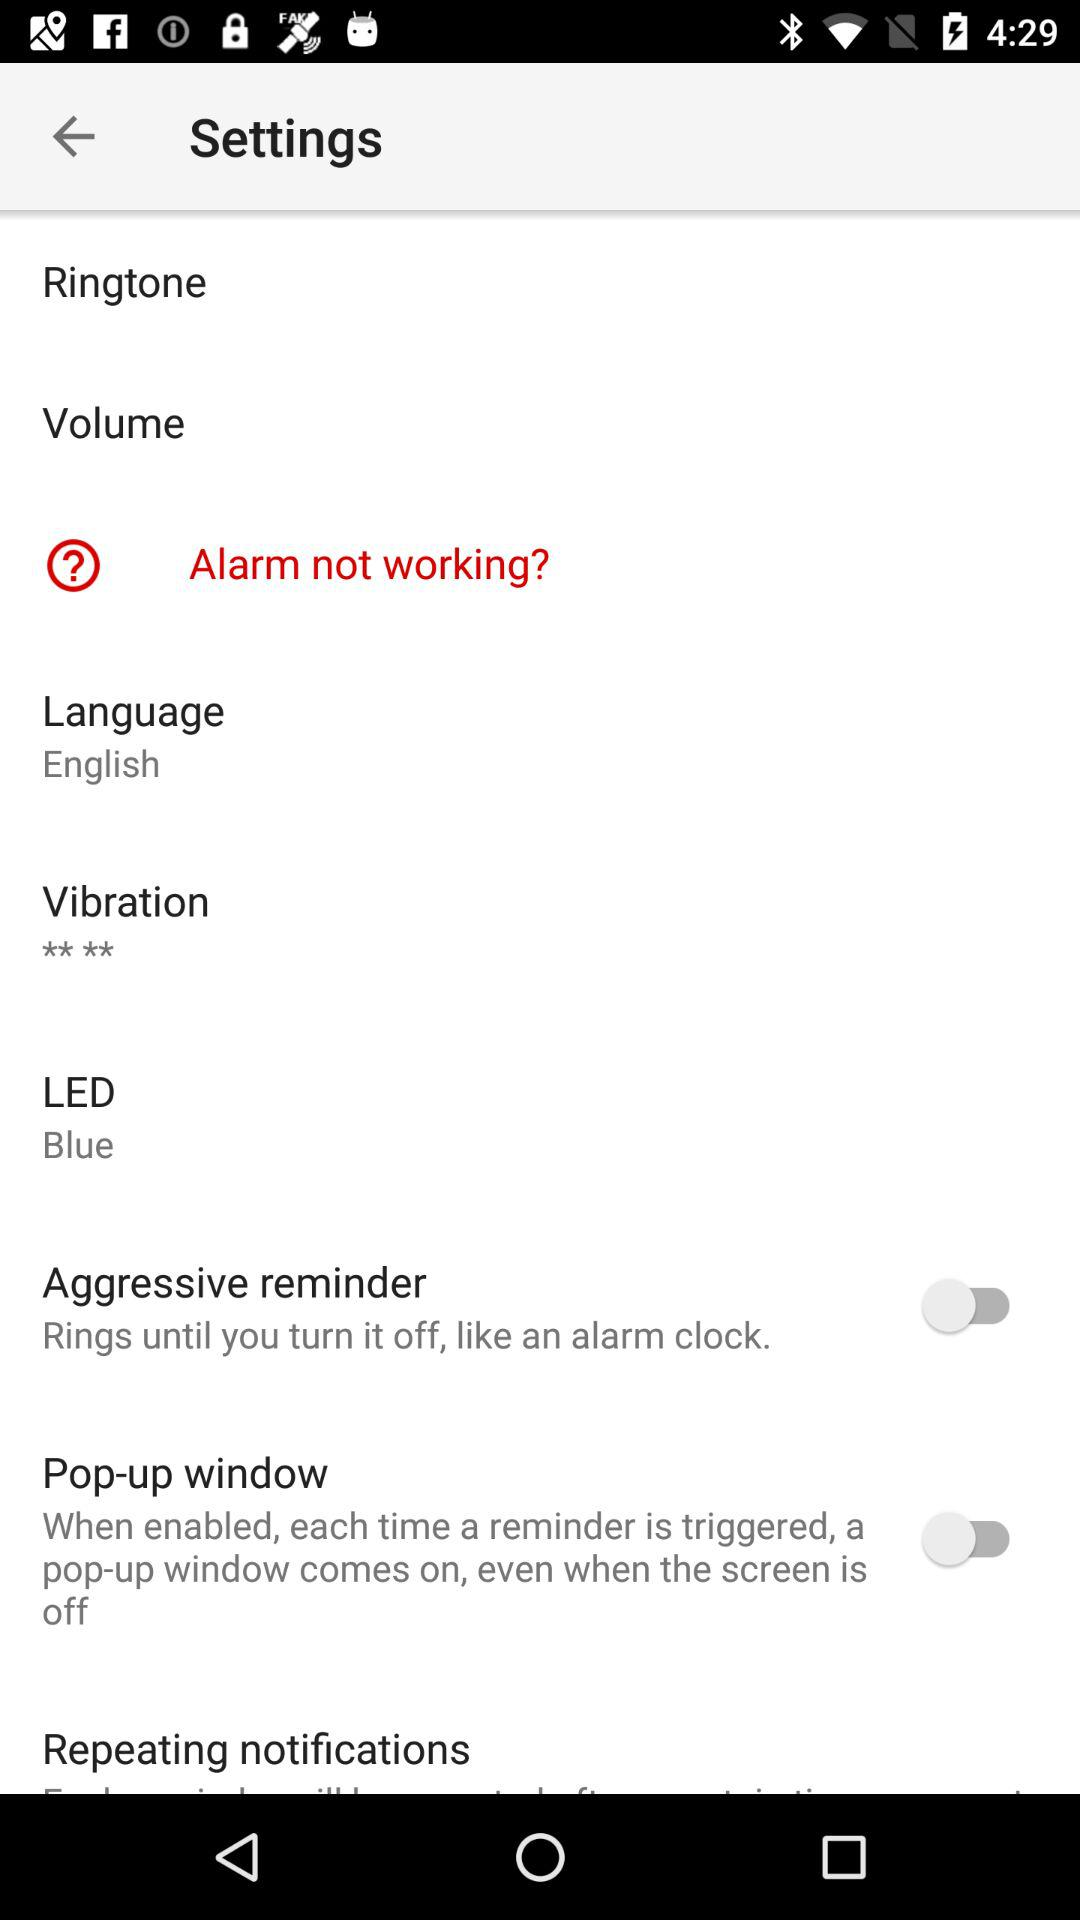Which is the selected language? The selected language is English. 